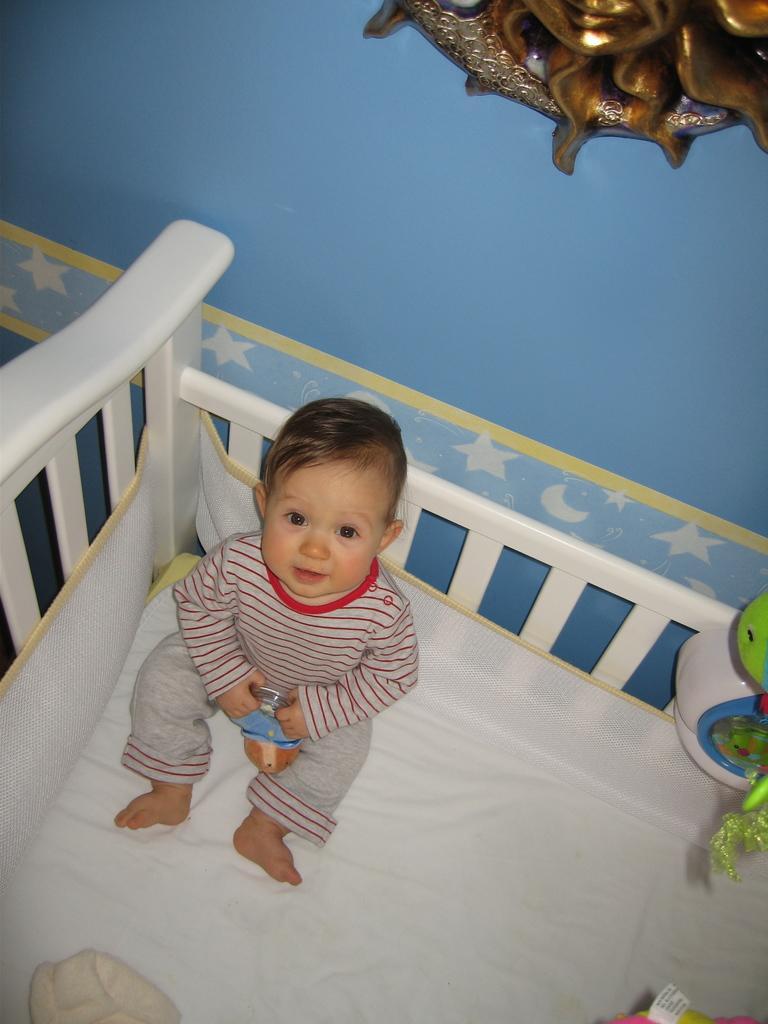In one or two sentences, can you explain what this image depicts? Baby is sitting on a bed and holding a toy. Decorative object on this blue wall. Here we can see things. On the wall there are pictures of stars and moons.  